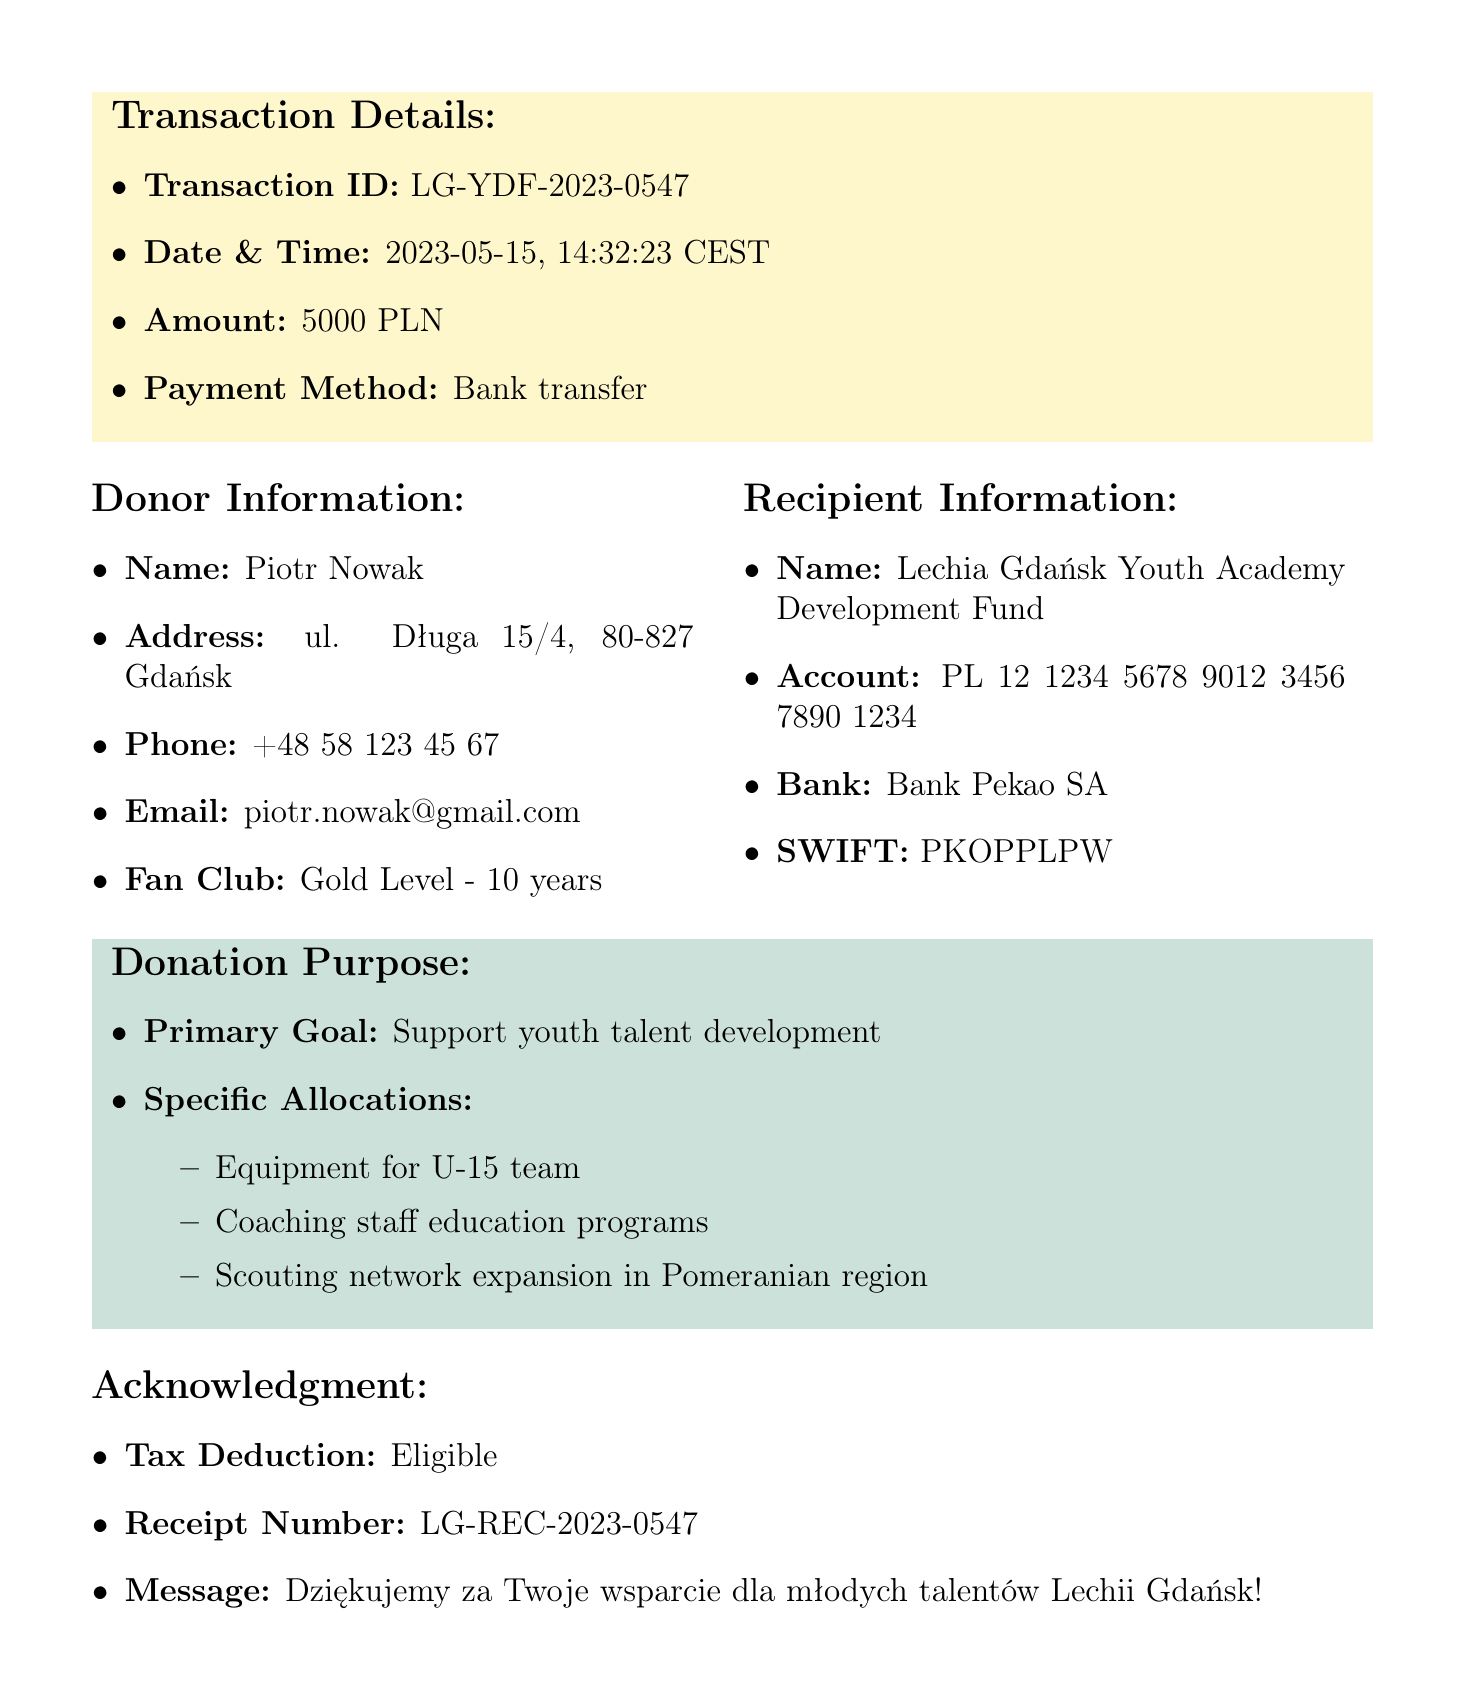What is the transaction ID? The transaction ID is specified in the transaction details section of the document.
Answer: LG-YDF-2023-0547 Who is the donor? The donor's name is listed under the donor information section.
Answer: Piotr Nowak What was the donation amount? The donation amount can be found in the transaction details section.
Answer: 5000 PLN Which bank was used for the donation? The bank used for the transaction is indicated in the recipient information section.
Answer: Bank Pekao SA What is the primary goal of the donation? The primary goal is outlined in the donation purpose section of the document.
Answer: Support youth talent development How many years has the donor been a fan club member? The duration of the donor's fan club membership is detailed in the donor information section.
Answer: 10 years What benefits does the donor receive? The benefits for the donor are enumerated in the donor benefits section of the document.
Answer: Name on the Youth Academy Supporters' Wall What is one of the specific allocations for the donation? The specific allocations for the donation can be found under the donation purpose section.
Answer: Equipment for U-15 team What is the long-term vision for the youth academy? The long-term vision is described in the future initiatives section.
Answer: Establish Lechia Gdańsk Youth Academy as the leading football development center in Northern Poland 